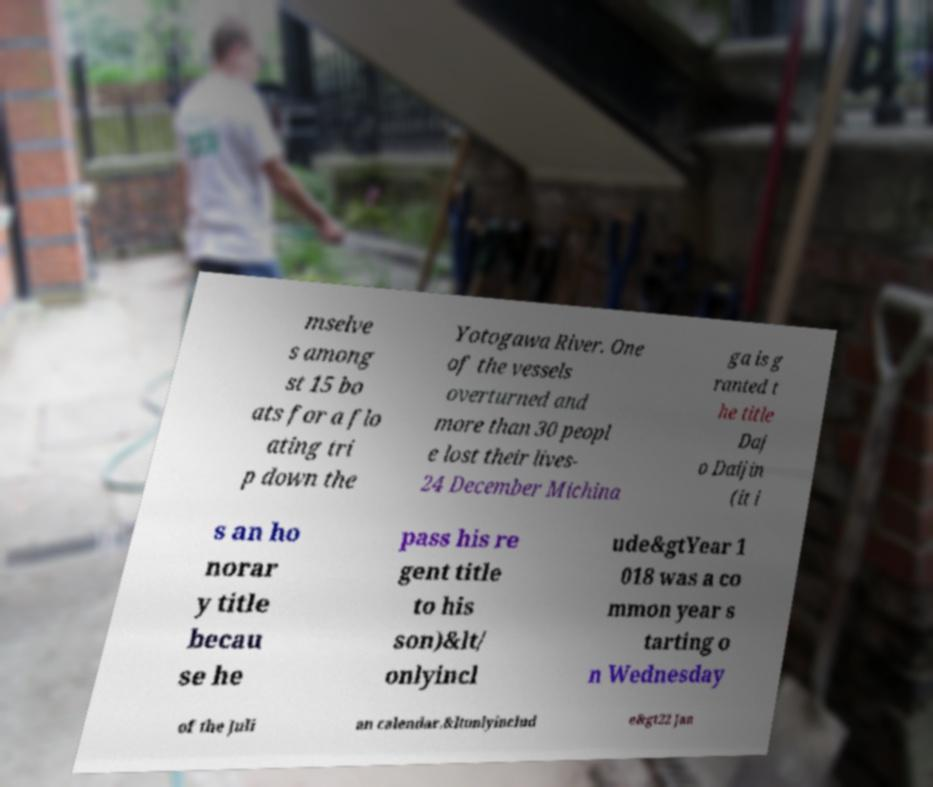Could you extract and type out the text from this image? mselve s among st 15 bo ats for a flo ating tri p down the Yotogawa River. One of the vessels overturned and more than 30 peopl e lost their lives- 24 December Michina ga is g ranted t he title Daj o Daijin (it i s an ho norar y title becau se he pass his re gent title to his son)&lt/ onlyincl ude&gtYear 1 018 was a co mmon year s tarting o n Wednesday of the Juli an calendar.&ltonlyinclud e&gt22 Jan 